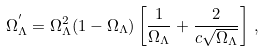Convert formula to latex. <formula><loc_0><loc_0><loc_500><loc_500>\Omega _ { \Lambda } ^ { ^ { \prime } } = \Omega _ { \Lambda } ^ { 2 } ( 1 - \Omega _ { \Lambda } ) \left [ \frac { 1 } { \Omega _ { \Lambda } } + \frac { 2 } { c \sqrt { \Omega _ { \Lambda } } } \right ] \, ,</formula> 